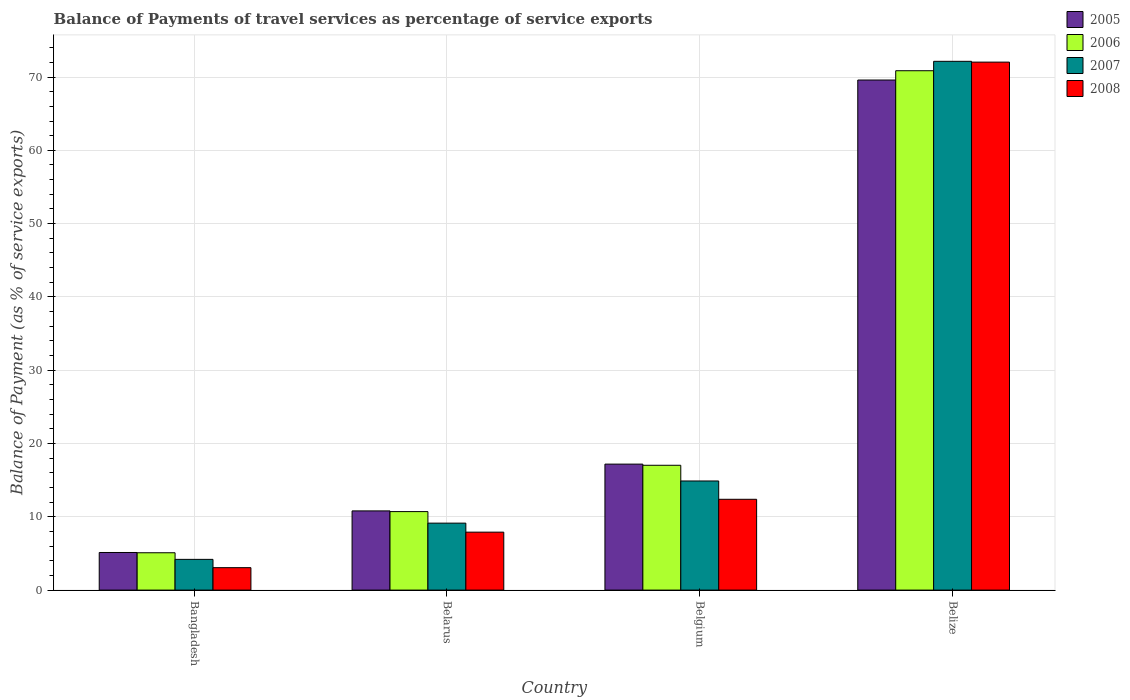How many different coloured bars are there?
Provide a short and direct response. 4. How many groups of bars are there?
Ensure brevity in your answer.  4. Are the number of bars on each tick of the X-axis equal?
Your response must be concise. Yes. What is the label of the 4th group of bars from the left?
Ensure brevity in your answer.  Belize. In how many cases, is the number of bars for a given country not equal to the number of legend labels?
Your answer should be very brief. 0. What is the balance of payments of travel services in 2007 in Belgium?
Your answer should be compact. 14.89. Across all countries, what is the maximum balance of payments of travel services in 2005?
Keep it short and to the point. 69.59. Across all countries, what is the minimum balance of payments of travel services in 2006?
Your response must be concise. 5.1. In which country was the balance of payments of travel services in 2005 maximum?
Offer a very short reply. Belize. What is the total balance of payments of travel services in 2007 in the graph?
Provide a succinct answer. 100.36. What is the difference between the balance of payments of travel services in 2005 in Belarus and that in Belize?
Provide a succinct answer. -58.78. What is the difference between the balance of payments of travel services in 2007 in Bangladesh and the balance of payments of travel services in 2008 in Belize?
Provide a succinct answer. -67.84. What is the average balance of payments of travel services in 2008 per country?
Provide a short and direct response. 23.85. What is the difference between the balance of payments of travel services of/in 2008 and balance of payments of travel services of/in 2005 in Bangladesh?
Offer a very short reply. -2.07. What is the ratio of the balance of payments of travel services in 2006 in Bangladesh to that in Belarus?
Offer a terse response. 0.48. Is the balance of payments of travel services in 2005 in Belarus less than that in Belize?
Your answer should be very brief. Yes. What is the difference between the highest and the second highest balance of payments of travel services in 2008?
Offer a very short reply. 59.65. What is the difference between the highest and the lowest balance of payments of travel services in 2007?
Provide a short and direct response. 67.95. Is the sum of the balance of payments of travel services in 2007 in Belarus and Belize greater than the maximum balance of payments of travel services in 2006 across all countries?
Make the answer very short. Yes. Is it the case that in every country, the sum of the balance of payments of travel services in 2005 and balance of payments of travel services in 2006 is greater than the balance of payments of travel services in 2007?
Make the answer very short. Yes. Are all the bars in the graph horizontal?
Make the answer very short. No. How many legend labels are there?
Your answer should be very brief. 4. What is the title of the graph?
Offer a very short reply. Balance of Payments of travel services as percentage of service exports. Does "1990" appear as one of the legend labels in the graph?
Offer a very short reply. No. What is the label or title of the X-axis?
Provide a short and direct response. Country. What is the label or title of the Y-axis?
Your response must be concise. Balance of Payment (as % of service exports). What is the Balance of Payment (as % of service exports) in 2005 in Bangladesh?
Make the answer very short. 5.13. What is the Balance of Payment (as % of service exports) in 2006 in Bangladesh?
Offer a very short reply. 5.1. What is the Balance of Payment (as % of service exports) of 2007 in Bangladesh?
Offer a terse response. 4.19. What is the Balance of Payment (as % of service exports) of 2008 in Bangladesh?
Ensure brevity in your answer.  3.06. What is the Balance of Payment (as % of service exports) in 2005 in Belarus?
Keep it short and to the point. 10.81. What is the Balance of Payment (as % of service exports) of 2006 in Belarus?
Provide a succinct answer. 10.71. What is the Balance of Payment (as % of service exports) of 2007 in Belarus?
Offer a very short reply. 9.14. What is the Balance of Payment (as % of service exports) of 2008 in Belarus?
Your response must be concise. 7.91. What is the Balance of Payment (as % of service exports) in 2005 in Belgium?
Ensure brevity in your answer.  17.19. What is the Balance of Payment (as % of service exports) in 2006 in Belgium?
Your answer should be very brief. 17.03. What is the Balance of Payment (as % of service exports) of 2007 in Belgium?
Provide a succinct answer. 14.89. What is the Balance of Payment (as % of service exports) in 2008 in Belgium?
Provide a short and direct response. 12.39. What is the Balance of Payment (as % of service exports) in 2005 in Belize?
Provide a succinct answer. 69.59. What is the Balance of Payment (as % of service exports) of 2006 in Belize?
Ensure brevity in your answer.  70.86. What is the Balance of Payment (as % of service exports) in 2007 in Belize?
Keep it short and to the point. 72.14. What is the Balance of Payment (as % of service exports) of 2008 in Belize?
Provide a succinct answer. 72.03. Across all countries, what is the maximum Balance of Payment (as % of service exports) of 2005?
Make the answer very short. 69.59. Across all countries, what is the maximum Balance of Payment (as % of service exports) of 2006?
Provide a succinct answer. 70.86. Across all countries, what is the maximum Balance of Payment (as % of service exports) in 2007?
Your answer should be compact. 72.14. Across all countries, what is the maximum Balance of Payment (as % of service exports) of 2008?
Offer a very short reply. 72.03. Across all countries, what is the minimum Balance of Payment (as % of service exports) of 2005?
Keep it short and to the point. 5.13. Across all countries, what is the minimum Balance of Payment (as % of service exports) in 2006?
Your answer should be very brief. 5.1. Across all countries, what is the minimum Balance of Payment (as % of service exports) in 2007?
Keep it short and to the point. 4.19. Across all countries, what is the minimum Balance of Payment (as % of service exports) in 2008?
Your response must be concise. 3.06. What is the total Balance of Payment (as % of service exports) in 2005 in the graph?
Offer a very short reply. 102.72. What is the total Balance of Payment (as % of service exports) in 2006 in the graph?
Provide a short and direct response. 103.69. What is the total Balance of Payment (as % of service exports) of 2007 in the graph?
Provide a succinct answer. 100.36. What is the total Balance of Payment (as % of service exports) of 2008 in the graph?
Offer a very short reply. 95.39. What is the difference between the Balance of Payment (as % of service exports) of 2005 in Bangladesh and that in Belarus?
Ensure brevity in your answer.  -5.67. What is the difference between the Balance of Payment (as % of service exports) in 2006 in Bangladesh and that in Belarus?
Keep it short and to the point. -5.61. What is the difference between the Balance of Payment (as % of service exports) in 2007 in Bangladesh and that in Belarus?
Provide a succinct answer. -4.94. What is the difference between the Balance of Payment (as % of service exports) of 2008 in Bangladesh and that in Belarus?
Give a very brief answer. -4.85. What is the difference between the Balance of Payment (as % of service exports) in 2005 in Bangladesh and that in Belgium?
Give a very brief answer. -12.06. What is the difference between the Balance of Payment (as % of service exports) in 2006 in Bangladesh and that in Belgium?
Offer a terse response. -11.94. What is the difference between the Balance of Payment (as % of service exports) of 2007 in Bangladesh and that in Belgium?
Provide a succinct answer. -10.69. What is the difference between the Balance of Payment (as % of service exports) of 2008 in Bangladesh and that in Belgium?
Provide a succinct answer. -9.33. What is the difference between the Balance of Payment (as % of service exports) in 2005 in Bangladesh and that in Belize?
Your answer should be compact. -64.46. What is the difference between the Balance of Payment (as % of service exports) in 2006 in Bangladesh and that in Belize?
Keep it short and to the point. -65.76. What is the difference between the Balance of Payment (as % of service exports) of 2007 in Bangladesh and that in Belize?
Your answer should be very brief. -67.95. What is the difference between the Balance of Payment (as % of service exports) of 2008 in Bangladesh and that in Belize?
Keep it short and to the point. -68.97. What is the difference between the Balance of Payment (as % of service exports) in 2005 in Belarus and that in Belgium?
Your response must be concise. -6.38. What is the difference between the Balance of Payment (as % of service exports) of 2006 in Belarus and that in Belgium?
Your response must be concise. -6.32. What is the difference between the Balance of Payment (as % of service exports) of 2007 in Belarus and that in Belgium?
Your answer should be very brief. -5.75. What is the difference between the Balance of Payment (as % of service exports) of 2008 in Belarus and that in Belgium?
Ensure brevity in your answer.  -4.48. What is the difference between the Balance of Payment (as % of service exports) in 2005 in Belarus and that in Belize?
Your response must be concise. -58.78. What is the difference between the Balance of Payment (as % of service exports) of 2006 in Belarus and that in Belize?
Provide a short and direct response. -60.15. What is the difference between the Balance of Payment (as % of service exports) in 2007 in Belarus and that in Belize?
Your answer should be compact. -63.01. What is the difference between the Balance of Payment (as % of service exports) of 2008 in Belarus and that in Belize?
Provide a succinct answer. -64.13. What is the difference between the Balance of Payment (as % of service exports) in 2005 in Belgium and that in Belize?
Your response must be concise. -52.4. What is the difference between the Balance of Payment (as % of service exports) in 2006 in Belgium and that in Belize?
Provide a succinct answer. -53.83. What is the difference between the Balance of Payment (as % of service exports) of 2007 in Belgium and that in Belize?
Offer a terse response. -57.26. What is the difference between the Balance of Payment (as % of service exports) in 2008 in Belgium and that in Belize?
Provide a succinct answer. -59.65. What is the difference between the Balance of Payment (as % of service exports) of 2005 in Bangladesh and the Balance of Payment (as % of service exports) of 2006 in Belarus?
Give a very brief answer. -5.58. What is the difference between the Balance of Payment (as % of service exports) in 2005 in Bangladesh and the Balance of Payment (as % of service exports) in 2007 in Belarus?
Make the answer very short. -4.01. What is the difference between the Balance of Payment (as % of service exports) of 2005 in Bangladesh and the Balance of Payment (as % of service exports) of 2008 in Belarus?
Your answer should be very brief. -2.78. What is the difference between the Balance of Payment (as % of service exports) of 2006 in Bangladesh and the Balance of Payment (as % of service exports) of 2007 in Belarus?
Offer a very short reply. -4.04. What is the difference between the Balance of Payment (as % of service exports) of 2006 in Bangladesh and the Balance of Payment (as % of service exports) of 2008 in Belarus?
Ensure brevity in your answer.  -2.81. What is the difference between the Balance of Payment (as % of service exports) of 2007 in Bangladesh and the Balance of Payment (as % of service exports) of 2008 in Belarus?
Your answer should be compact. -3.71. What is the difference between the Balance of Payment (as % of service exports) in 2005 in Bangladesh and the Balance of Payment (as % of service exports) in 2006 in Belgium?
Your answer should be very brief. -11.9. What is the difference between the Balance of Payment (as % of service exports) of 2005 in Bangladesh and the Balance of Payment (as % of service exports) of 2007 in Belgium?
Your answer should be compact. -9.76. What is the difference between the Balance of Payment (as % of service exports) of 2005 in Bangladesh and the Balance of Payment (as % of service exports) of 2008 in Belgium?
Keep it short and to the point. -7.26. What is the difference between the Balance of Payment (as % of service exports) in 2006 in Bangladesh and the Balance of Payment (as % of service exports) in 2007 in Belgium?
Make the answer very short. -9.79. What is the difference between the Balance of Payment (as % of service exports) in 2006 in Bangladesh and the Balance of Payment (as % of service exports) in 2008 in Belgium?
Your answer should be compact. -7.29. What is the difference between the Balance of Payment (as % of service exports) in 2007 in Bangladesh and the Balance of Payment (as % of service exports) in 2008 in Belgium?
Give a very brief answer. -8.2. What is the difference between the Balance of Payment (as % of service exports) of 2005 in Bangladesh and the Balance of Payment (as % of service exports) of 2006 in Belize?
Provide a succinct answer. -65.73. What is the difference between the Balance of Payment (as % of service exports) of 2005 in Bangladesh and the Balance of Payment (as % of service exports) of 2007 in Belize?
Your answer should be compact. -67.01. What is the difference between the Balance of Payment (as % of service exports) of 2005 in Bangladesh and the Balance of Payment (as % of service exports) of 2008 in Belize?
Make the answer very short. -66.9. What is the difference between the Balance of Payment (as % of service exports) of 2006 in Bangladesh and the Balance of Payment (as % of service exports) of 2007 in Belize?
Ensure brevity in your answer.  -67.05. What is the difference between the Balance of Payment (as % of service exports) of 2006 in Bangladesh and the Balance of Payment (as % of service exports) of 2008 in Belize?
Make the answer very short. -66.94. What is the difference between the Balance of Payment (as % of service exports) of 2007 in Bangladesh and the Balance of Payment (as % of service exports) of 2008 in Belize?
Offer a terse response. -67.84. What is the difference between the Balance of Payment (as % of service exports) of 2005 in Belarus and the Balance of Payment (as % of service exports) of 2006 in Belgium?
Your answer should be compact. -6.23. What is the difference between the Balance of Payment (as % of service exports) in 2005 in Belarus and the Balance of Payment (as % of service exports) in 2007 in Belgium?
Your answer should be compact. -4.08. What is the difference between the Balance of Payment (as % of service exports) in 2005 in Belarus and the Balance of Payment (as % of service exports) in 2008 in Belgium?
Give a very brief answer. -1.58. What is the difference between the Balance of Payment (as % of service exports) in 2006 in Belarus and the Balance of Payment (as % of service exports) in 2007 in Belgium?
Your answer should be compact. -4.18. What is the difference between the Balance of Payment (as % of service exports) in 2006 in Belarus and the Balance of Payment (as % of service exports) in 2008 in Belgium?
Offer a very short reply. -1.68. What is the difference between the Balance of Payment (as % of service exports) in 2007 in Belarus and the Balance of Payment (as % of service exports) in 2008 in Belgium?
Your answer should be very brief. -3.25. What is the difference between the Balance of Payment (as % of service exports) of 2005 in Belarus and the Balance of Payment (as % of service exports) of 2006 in Belize?
Provide a short and direct response. -60.05. What is the difference between the Balance of Payment (as % of service exports) in 2005 in Belarus and the Balance of Payment (as % of service exports) in 2007 in Belize?
Provide a succinct answer. -61.34. What is the difference between the Balance of Payment (as % of service exports) of 2005 in Belarus and the Balance of Payment (as % of service exports) of 2008 in Belize?
Offer a terse response. -61.23. What is the difference between the Balance of Payment (as % of service exports) of 2006 in Belarus and the Balance of Payment (as % of service exports) of 2007 in Belize?
Your answer should be compact. -61.43. What is the difference between the Balance of Payment (as % of service exports) of 2006 in Belarus and the Balance of Payment (as % of service exports) of 2008 in Belize?
Offer a terse response. -61.33. What is the difference between the Balance of Payment (as % of service exports) in 2007 in Belarus and the Balance of Payment (as % of service exports) in 2008 in Belize?
Keep it short and to the point. -62.9. What is the difference between the Balance of Payment (as % of service exports) of 2005 in Belgium and the Balance of Payment (as % of service exports) of 2006 in Belize?
Your answer should be very brief. -53.67. What is the difference between the Balance of Payment (as % of service exports) in 2005 in Belgium and the Balance of Payment (as % of service exports) in 2007 in Belize?
Provide a short and direct response. -54.95. What is the difference between the Balance of Payment (as % of service exports) of 2005 in Belgium and the Balance of Payment (as % of service exports) of 2008 in Belize?
Ensure brevity in your answer.  -54.85. What is the difference between the Balance of Payment (as % of service exports) in 2006 in Belgium and the Balance of Payment (as % of service exports) in 2007 in Belize?
Offer a very short reply. -55.11. What is the difference between the Balance of Payment (as % of service exports) of 2006 in Belgium and the Balance of Payment (as % of service exports) of 2008 in Belize?
Keep it short and to the point. -55. What is the difference between the Balance of Payment (as % of service exports) in 2007 in Belgium and the Balance of Payment (as % of service exports) in 2008 in Belize?
Offer a terse response. -57.15. What is the average Balance of Payment (as % of service exports) of 2005 per country?
Ensure brevity in your answer.  25.68. What is the average Balance of Payment (as % of service exports) in 2006 per country?
Your response must be concise. 25.92. What is the average Balance of Payment (as % of service exports) in 2007 per country?
Offer a terse response. 25.09. What is the average Balance of Payment (as % of service exports) in 2008 per country?
Provide a short and direct response. 23.85. What is the difference between the Balance of Payment (as % of service exports) of 2005 and Balance of Payment (as % of service exports) of 2006 in Bangladesh?
Make the answer very short. 0.04. What is the difference between the Balance of Payment (as % of service exports) of 2005 and Balance of Payment (as % of service exports) of 2007 in Bangladesh?
Give a very brief answer. 0.94. What is the difference between the Balance of Payment (as % of service exports) of 2005 and Balance of Payment (as % of service exports) of 2008 in Bangladesh?
Give a very brief answer. 2.07. What is the difference between the Balance of Payment (as % of service exports) of 2006 and Balance of Payment (as % of service exports) of 2007 in Bangladesh?
Make the answer very short. 0.9. What is the difference between the Balance of Payment (as % of service exports) in 2006 and Balance of Payment (as % of service exports) in 2008 in Bangladesh?
Your answer should be compact. 2.04. What is the difference between the Balance of Payment (as % of service exports) in 2007 and Balance of Payment (as % of service exports) in 2008 in Bangladesh?
Your answer should be very brief. 1.13. What is the difference between the Balance of Payment (as % of service exports) in 2005 and Balance of Payment (as % of service exports) in 2006 in Belarus?
Keep it short and to the point. 0.1. What is the difference between the Balance of Payment (as % of service exports) in 2005 and Balance of Payment (as % of service exports) in 2007 in Belarus?
Provide a succinct answer. 1.67. What is the difference between the Balance of Payment (as % of service exports) of 2005 and Balance of Payment (as % of service exports) of 2008 in Belarus?
Provide a short and direct response. 2.9. What is the difference between the Balance of Payment (as % of service exports) of 2006 and Balance of Payment (as % of service exports) of 2007 in Belarus?
Offer a terse response. 1.57. What is the difference between the Balance of Payment (as % of service exports) of 2006 and Balance of Payment (as % of service exports) of 2008 in Belarus?
Keep it short and to the point. 2.8. What is the difference between the Balance of Payment (as % of service exports) in 2007 and Balance of Payment (as % of service exports) in 2008 in Belarus?
Ensure brevity in your answer.  1.23. What is the difference between the Balance of Payment (as % of service exports) in 2005 and Balance of Payment (as % of service exports) in 2006 in Belgium?
Your answer should be very brief. 0.16. What is the difference between the Balance of Payment (as % of service exports) in 2005 and Balance of Payment (as % of service exports) in 2007 in Belgium?
Provide a short and direct response. 2.3. What is the difference between the Balance of Payment (as % of service exports) in 2005 and Balance of Payment (as % of service exports) in 2008 in Belgium?
Provide a succinct answer. 4.8. What is the difference between the Balance of Payment (as % of service exports) in 2006 and Balance of Payment (as % of service exports) in 2007 in Belgium?
Provide a short and direct response. 2.14. What is the difference between the Balance of Payment (as % of service exports) in 2006 and Balance of Payment (as % of service exports) in 2008 in Belgium?
Ensure brevity in your answer.  4.64. What is the difference between the Balance of Payment (as % of service exports) in 2007 and Balance of Payment (as % of service exports) in 2008 in Belgium?
Offer a terse response. 2.5. What is the difference between the Balance of Payment (as % of service exports) of 2005 and Balance of Payment (as % of service exports) of 2006 in Belize?
Offer a terse response. -1.27. What is the difference between the Balance of Payment (as % of service exports) in 2005 and Balance of Payment (as % of service exports) in 2007 in Belize?
Offer a terse response. -2.55. What is the difference between the Balance of Payment (as % of service exports) of 2005 and Balance of Payment (as % of service exports) of 2008 in Belize?
Make the answer very short. -2.44. What is the difference between the Balance of Payment (as % of service exports) of 2006 and Balance of Payment (as % of service exports) of 2007 in Belize?
Provide a succinct answer. -1.28. What is the difference between the Balance of Payment (as % of service exports) of 2006 and Balance of Payment (as % of service exports) of 2008 in Belize?
Offer a very short reply. -1.18. What is the difference between the Balance of Payment (as % of service exports) of 2007 and Balance of Payment (as % of service exports) of 2008 in Belize?
Your answer should be compact. 0.11. What is the ratio of the Balance of Payment (as % of service exports) of 2005 in Bangladesh to that in Belarus?
Offer a very short reply. 0.47. What is the ratio of the Balance of Payment (as % of service exports) in 2006 in Bangladesh to that in Belarus?
Give a very brief answer. 0.48. What is the ratio of the Balance of Payment (as % of service exports) in 2007 in Bangladesh to that in Belarus?
Make the answer very short. 0.46. What is the ratio of the Balance of Payment (as % of service exports) in 2008 in Bangladesh to that in Belarus?
Make the answer very short. 0.39. What is the ratio of the Balance of Payment (as % of service exports) of 2005 in Bangladesh to that in Belgium?
Offer a terse response. 0.3. What is the ratio of the Balance of Payment (as % of service exports) of 2006 in Bangladesh to that in Belgium?
Offer a terse response. 0.3. What is the ratio of the Balance of Payment (as % of service exports) in 2007 in Bangladesh to that in Belgium?
Your answer should be compact. 0.28. What is the ratio of the Balance of Payment (as % of service exports) in 2008 in Bangladesh to that in Belgium?
Provide a succinct answer. 0.25. What is the ratio of the Balance of Payment (as % of service exports) of 2005 in Bangladesh to that in Belize?
Provide a short and direct response. 0.07. What is the ratio of the Balance of Payment (as % of service exports) of 2006 in Bangladesh to that in Belize?
Give a very brief answer. 0.07. What is the ratio of the Balance of Payment (as % of service exports) of 2007 in Bangladesh to that in Belize?
Your response must be concise. 0.06. What is the ratio of the Balance of Payment (as % of service exports) in 2008 in Bangladesh to that in Belize?
Offer a very short reply. 0.04. What is the ratio of the Balance of Payment (as % of service exports) of 2005 in Belarus to that in Belgium?
Your response must be concise. 0.63. What is the ratio of the Balance of Payment (as % of service exports) of 2006 in Belarus to that in Belgium?
Ensure brevity in your answer.  0.63. What is the ratio of the Balance of Payment (as % of service exports) in 2007 in Belarus to that in Belgium?
Your answer should be very brief. 0.61. What is the ratio of the Balance of Payment (as % of service exports) of 2008 in Belarus to that in Belgium?
Offer a terse response. 0.64. What is the ratio of the Balance of Payment (as % of service exports) of 2005 in Belarus to that in Belize?
Keep it short and to the point. 0.16. What is the ratio of the Balance of Payment (as % of service exports) in 2006 in Belarus to that in Belize?
Keep it short and to the point. 0.15. What is the ratio of the Balance of Payment (as % of service exports) in 2007 in Belarus to that in Belize?
Keep it short and to the point. 0.13. What is the ratio of the Balance of Payment (as % of service exports) of 2008 in Belarus to that in Belize?
Keep it short and to the point. 0.11. What is the ratio of the Balance of Payment (as % of service exports) of 2005 in Belgium to that in Belize?
Offer a terse response. 0.25. What is the ratio of the Balance of Payment (as % of service exports) in 2006 in Belgium to that in Belize?
Provide a succinct answer. 0.24. What is the ratio of the Balance of Payment (as % of service exports) of 2007 in Belgium to that in Belize?
Ensure brevity in your answer.  0.21. What is the ratio of the Balance of Payment (as % of service exports) in 2008 in Belgium to that in Belize?
Your answer should be very brief. 0.17. What is the difference between the highest and the second highest Balance of Payment (as % of service exports) in 2005?
Your response must be concise. 52.4. What is the difference between the highest and the second highest Balance of Payment (as % of service exports) in 2006?
Your answer should be very brief. 53.83. What is the difference between the highest and the second highest Balance of Payment (as % of service exports) in 2007?
Keep it short and to the point. 57.26. What is the difference between the highest and the second highest Balance of Payment (as % of service exports) of 2008?
Offer a terse response. 59.65. What is the difference between the highest and the lowest Balance of Payment (as % of service exports) in 2005?
Give a very brief answer. 64.46. What is the difference between the highest and the lowest Balance of Payment (as % of service exports) in 2006?
Give a very brief answer. 65.76. What is the difference between the highest and the lowest Balance of Payment (as % of service exports) of 2007?
Provide a short and direct response. 67.95. What is the difference between the highest and the lowest Balance of Payment (as % of service exports) in 2008?
Your answer should be compact. 68.97. 